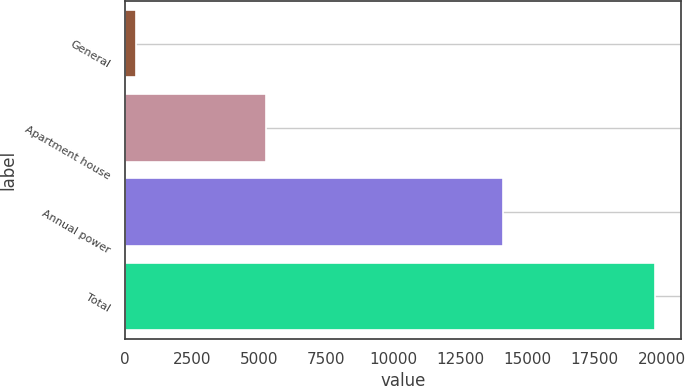<chart> <loc_0><loc_0><loc_500><loc_500><bar_chart><fcel>General<fcel>Apartment house<fcel>Annual power<fcel>Total<nl><fcel>425<fcel>5240<fcel>14076<fcel>19741<nl></chart> 